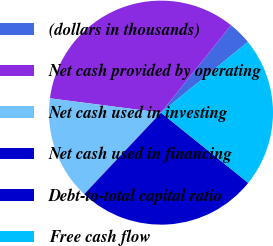Convert chart. <chart><loc_0><loc_0><loc_500><loc_500><pie_chart><fcel>(dollars in thousands)<fcel>Net cash provided by operating<fcel>Net cash used in investing<fcel>Net cash used in financing<fcel>Debt-to-total capital ratio<fcel>Free cash flow<nl><fcel>3.37%<fcel>33.71%<fcel>15.01%<fcel>26.23%<fcel>0.0%<fcel>21.67%<nl></chart> 